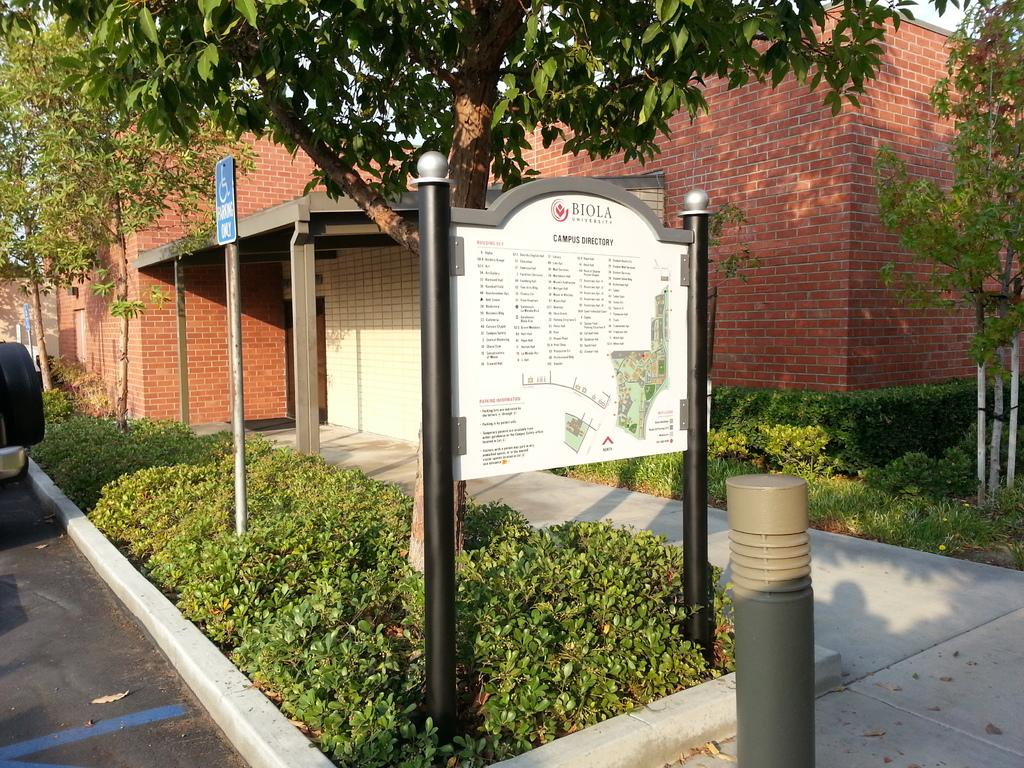What type of structures can be seen in the image? There are houses in the image. What type of vegetation is present in the image? There are plants, trees, and poles in the image. What type of surface is visible on the left side of the image? There is a road on the left side of the image. What type of path is visible at the bottom of the image? There is a walkway at the bottom of the image. Where is the toothpaste located in the image? There is no toothpaste present in the image. What type of picture is hanging on the wall in the image? There is no picture hanging on the wall in the image. 